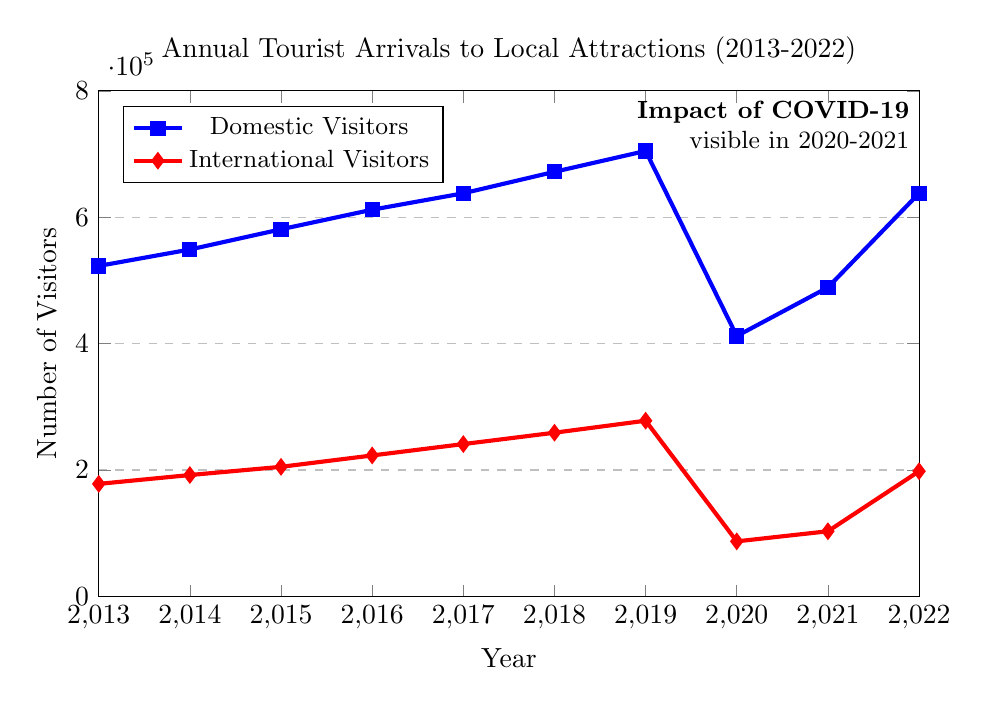What's the overall trend in the number of domestic visitors from 2013 to 2022? The plot shows a generally increasing trend from 2013 to 2019, a sharp decline in 2020 and 2021, and a recovery in 2022.
Answer: Increasing In which year was the number of international visitors the lowest? By examining the plotted data, the number of international visitors was the lowest in the year 2020.
Answer: 2020 What is the total number of visitors (domestic and international) to local attractions in 2019? Add the domestic visitors and international visitors for the year 2019: 705,000 (domestic) + 278,000 (international) = 983,000.
Answer: 983,000 Compare the number of domestic vs. international visitors in 2022. Which group had more visitors, and by how much? In 2022, domestic visitors were 638,000 and international visitors were 198,000. The difference is 638,000 - 198,000 = 440,000.
Answer: Domestic visitors by 440,000 How did the number of domestic visitors change from 2019 to 2020? The number of domestic visitors in 2019 was 705,000 and in 2020 it was 412,000. The change is 705,000 - 412,000 = 293,000 decrease.
Answer: Decreased by 293,000 What can be inferred about the impact of COVID-19 from the plot? From the plot, a significant drop in both domestic and international visitors is observed in 2020 and 2021, indicating the impact of COVID-19.
Answer: Significant drop What's the average annual number of international visitors from 2013 to 2022? Sum the international visitors for all years: 178,000 + 192,000 + 205,000 + 223,000 + 241,000 + 259,000 + 278,000 + 87,000 + 103,000 + 198,000 = 1,964,000. Average is 1,964,000/10 = 196,400.
Answer: 196,400 Identify the years when both domestic and international visitors increased compared to their previous year. By examining the plot, the years are 2014, 2015, 2016, 2017, 2018, and 2019.
Answer: 2014, 2015, 2016, 2017, 2018, 2019 How did the number of international visitors in 2021 compare to 2015? In 2015, there were 205,000 international visitors, and in 2021, there were 103,000 international visitors. Comparison shows a decrease: 205,000 - 103,000 = 102,000.
Answer: Decreased by 102,000 What is the visual difference between the data points for domestic and international visitors in 2020? The data point for domestic visitors is marked with a blue square at 412,000, and for international visitors with a red diamond at 87,000, showing a wider gap and sharp decline due to COVID-19.
Answer: Blue square at 412,000 and red diamond at 87,000 